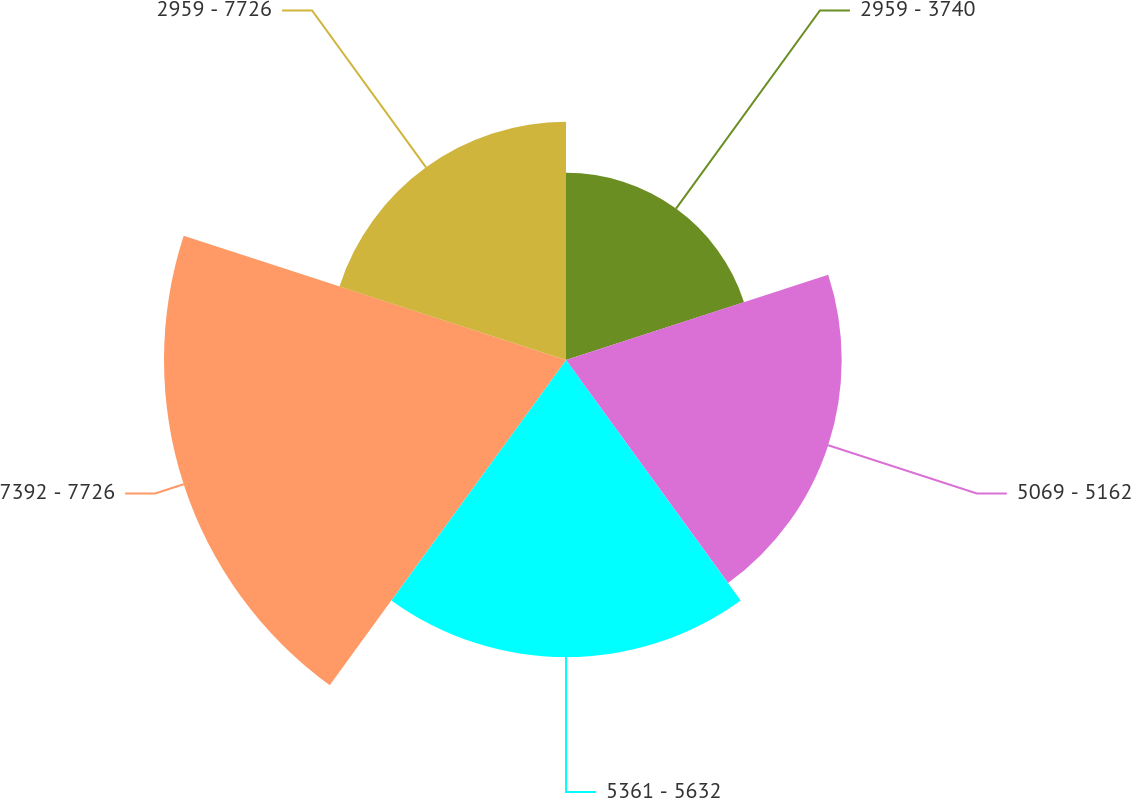Convert chart. <chart><loc_0><loc_0><loc_500><loc_500><pie_chart><fcel>2959 - 3740<fcel>5069 - 5162<fcel>5361 - 5632<fcel>7392 - 7726<fcel>2959 - 7726<nl><fcel>13.37%<fcel>19.69%<fcel>21.22%<fcel>28.71%<fcel>17.01%<nl></chart> 